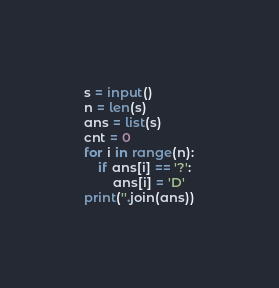Convert code to text. <code><loc_0><loc_0><loc_500><loc_500><_Python_>s = input()
n = len(s)
ans = list(s)
cnt = 0
for i in range(n):
    if ans[i] == '?':
        ans[i] = 'D'
print(''.join(ans))
</code> 